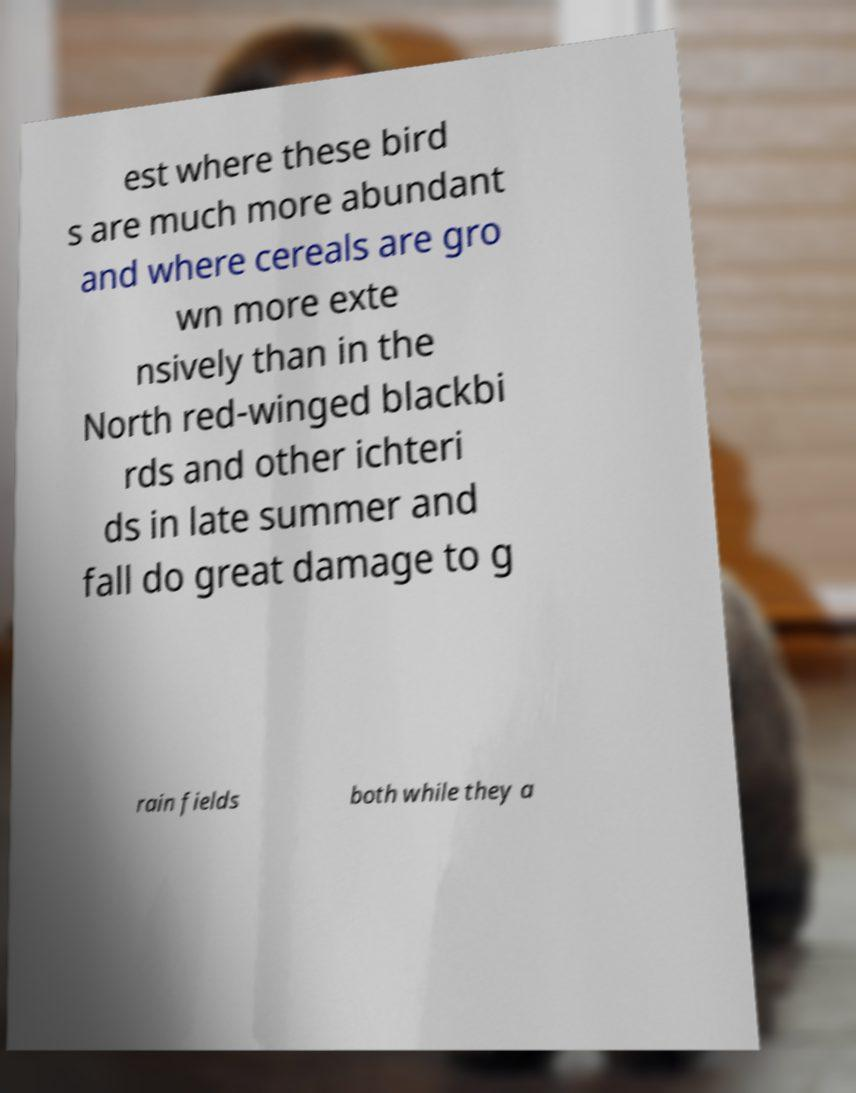Could you assist in decoding the text presented in this image and type it out clearly? est where these bird s are much more abundant and where cereals are gro wn more exte nsively than in the North red-winged blackbi rds and other ichteri ds in late summer and fall do great damage to g rain fields both while they a 